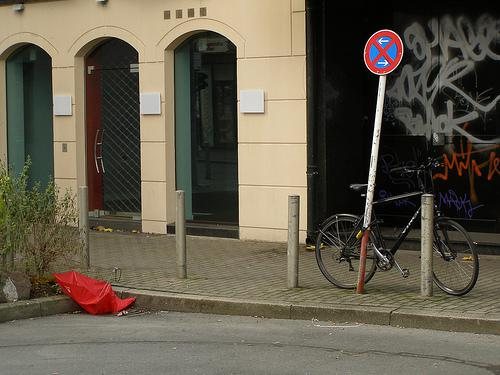Question: where is the umbrella?
Choices:
A. In the street.
B. On the sidewalk.
C. On the porch.
D. On the grass.
Answer with the letter. Answer: A Question: how many brown squares are above the third doorway?
Choices:
A. Six.
B. Seven.
C. Eight.
D. Four.
Answer with the letter. Answer: D Question: how is the bike secured to the pole?
Choices:
A. With rope.
B. With a chain.
C. With wires.
D. With a lock.
Answer with the letter. Answer: D Question: how many doorways are in the picture?
Choices:
A. Three.
B. Two.
C. One.
D. Five.
Answer with the letter. Answer: A 